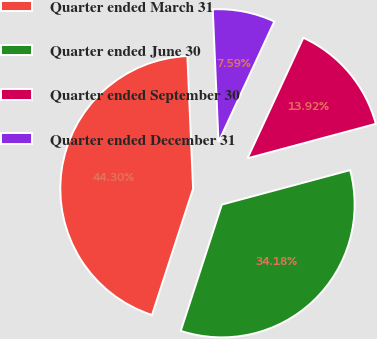<chart> <loc_0><loc_0><loc_500><loc_500><pie_chart><fcel>Quarter ended March 31<fcel>Quarter ended June 30<fcel>Quarter ended September 30<fcel>Quarter ended December 31<nl><fcel>44.3%<fcel>34.18%<fcel>13.92%<fcel>7.59%<nl></chart> 